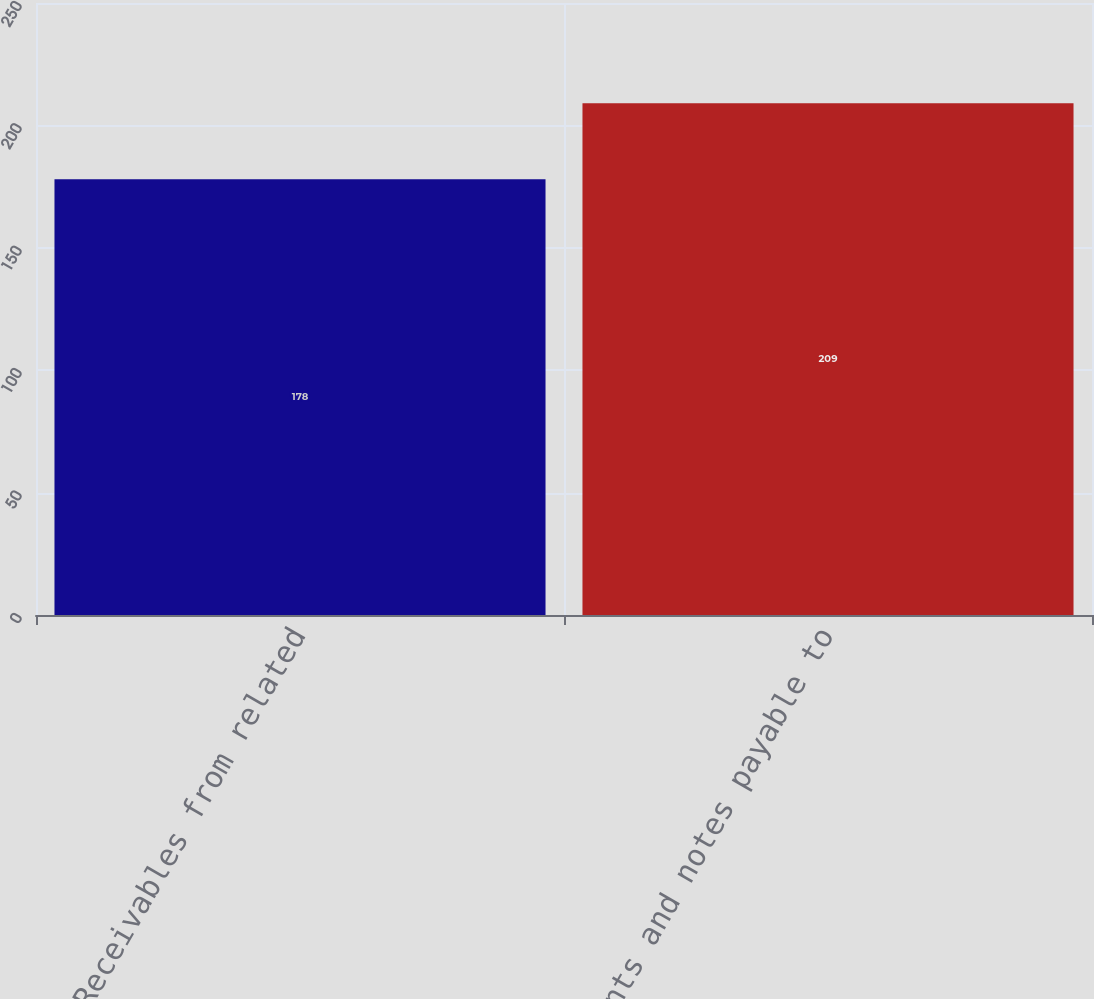Convert chart. <chart><loc_0><loc_0><loc_500><loc_500><bar_chart><fcel>Receivables from related<fcel>Accounts and notes payable to<nl><fcel>178<fcel>209<nl></chart> 